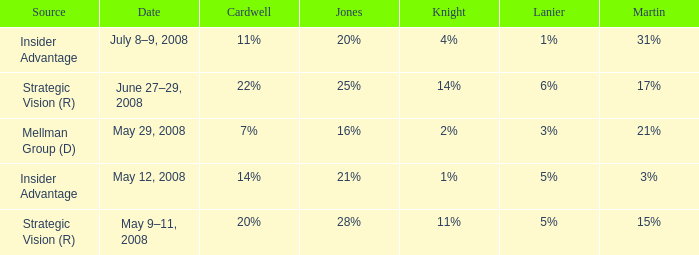What cardwell possesses an insider benefit and a knight of 1%? 14%. 